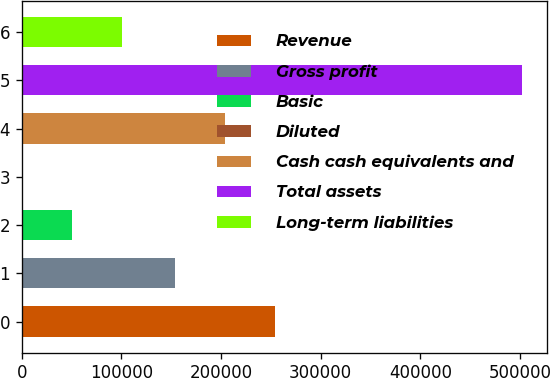Convert chart to OTSL. <chart><loc_0><loc_0><loc_500><loc_500><bar_chart><fcel>Revenue<fcel>Gross profit<fcel>Basic<fcel>Diluted<fcel>Cash cash equivalents and<fcel>Total assets<fcel>Long-term liabilities<nl><fcel>253886<fcel>153569<fcel>50161<fcel>2.51<fcel>203727<fcel>501587<fcel>100319<nl></chart> 